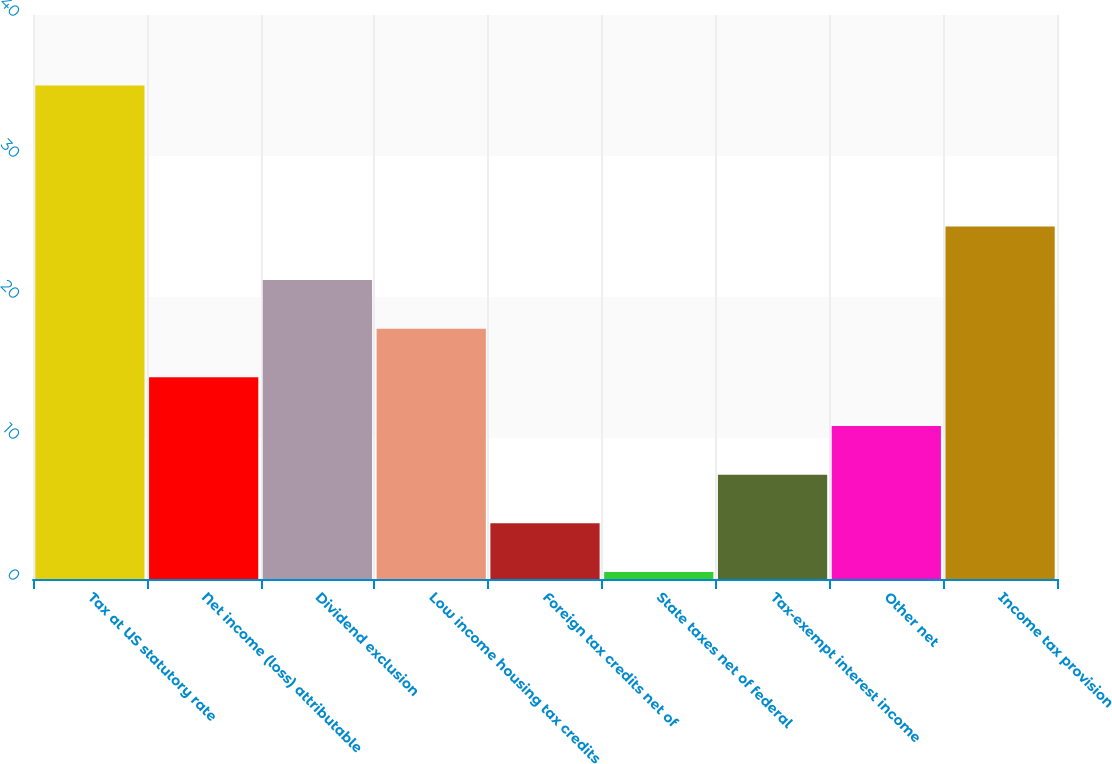<chart> <loc_0><loc_0><loc_500><loc_500><bar_chart><fcel>Tax at US statutory rate<fcel>Net income (loss) attributable<fcel>Dividend exclusion<fcel>Low income housing tax credits<fcel>Foreign tax credits net of<fcel>State taxes net of federal<fcel>Tax-exempt interest income<fcel>Other net<fcel>Income tax provision<nl><fcel>35<fcel>14.3<fcel>21.2<fcel>17.75<fcel>3.95<fcel>0.5<fcel>7.4<fcel>10.85<fcel>25<nl></chart> 